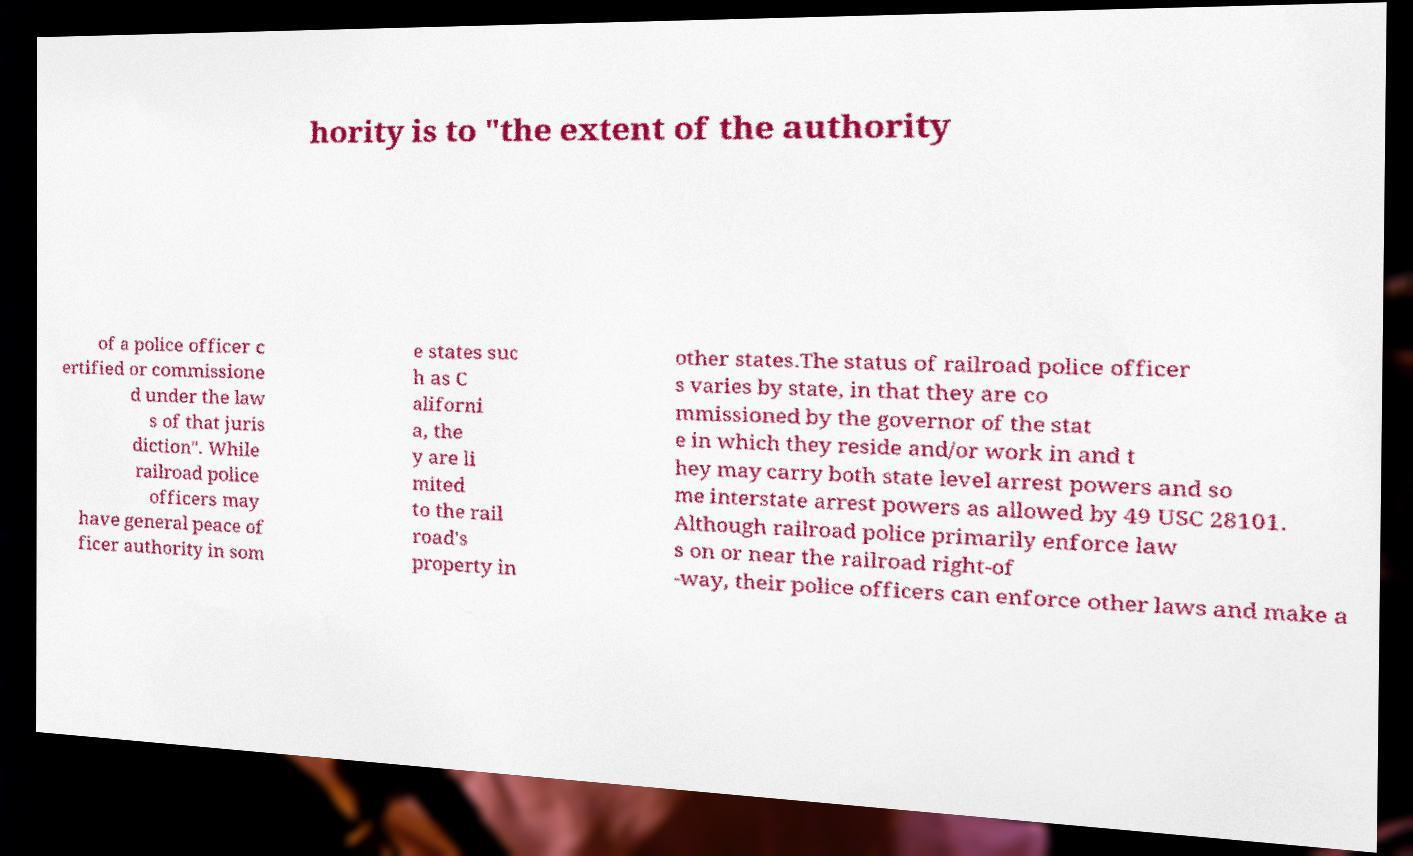Can you read and provide the text displayed in the image?This photo seems to have some interesting text. Can you extract and type it out for me? hority is to "the extent of the authority of a police officer c ertified or commissione d under the law s of that juris diction". While railroad police officers may have general peace of ficer authority in som e states suc h as C aliforni a, the y are li mited to the rail road's property in other states.The status of railroad police officer s varies by state, in that they are co mmissioned by the governor of the stat e in which they reside and/or work in and t hey may carry both state level arrest powers and so me interstate arrest powers as allowed by 49 USC 28101. Although railroad police primarily enforce law s on or near the railroad right-of -way, their police officers can enforce other laws and make a 